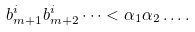Convert formula to latex. <formula><loc_0><loc_0><loc_500><loc_500>b _ { m + 1 } ^ { i } b _ { m + 2 } ^ { i } \dots < \alpha _ { 1 } \alpha _ { 2 } \dots .</formula> 